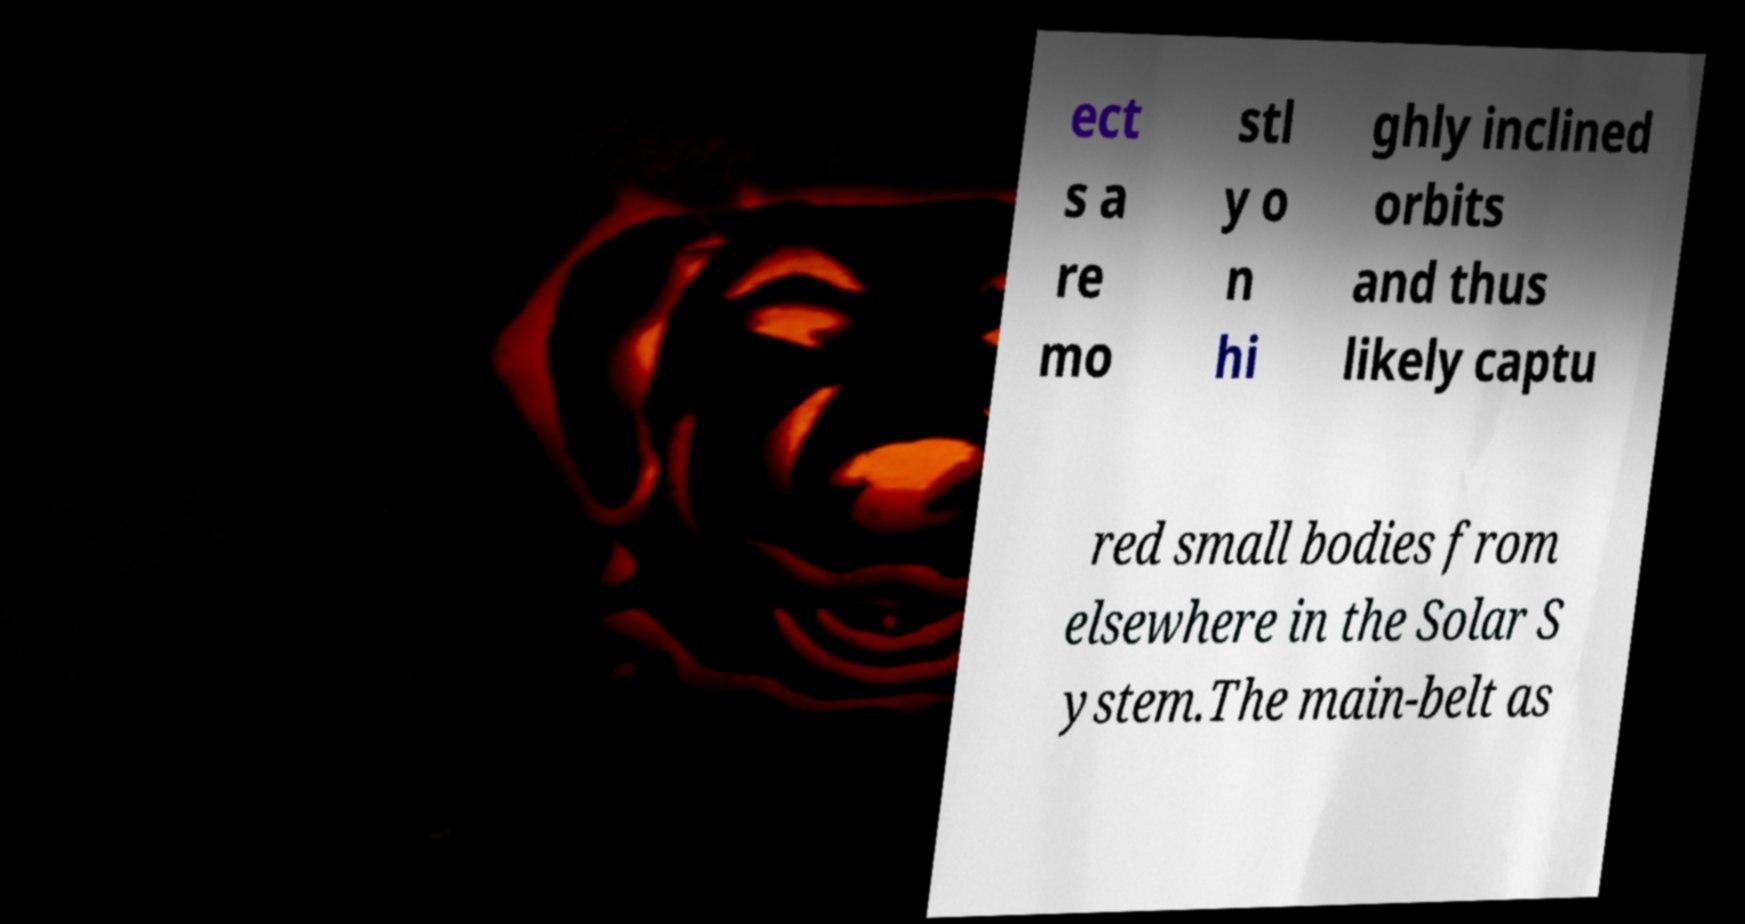Please identify and transcribe the text found in this image. ect s a re mo stl y o n hi ghly inclined orbits and thus likely captu red small bodies from elsewhere in the Solar S ystem.The main-belt as 